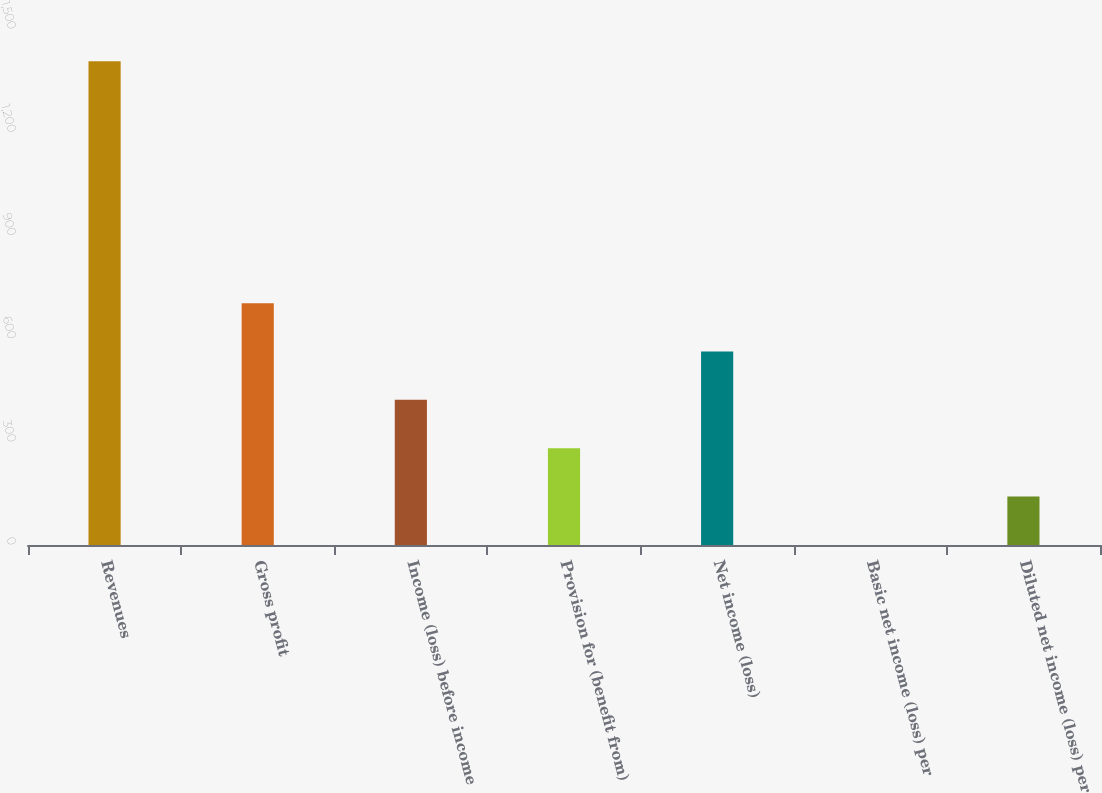<chart> <loc_0><loc_0><loc_500><loc_500><bar_chart><fcel>Revenues<fcel>Gross profit<fcel>Income (loss) before income<fcel>Provision for (benefit from)<fcel>Net income (loss)<fcel>Basic net income (loss) per<fcel>Diluted net income (loss) per<nl><fcel>1406.1<fcel>703.11<fcel>421.93<fcel>281.34<fcel>562.52<fcel>0.16<fcel>140.75<nl></chart> 